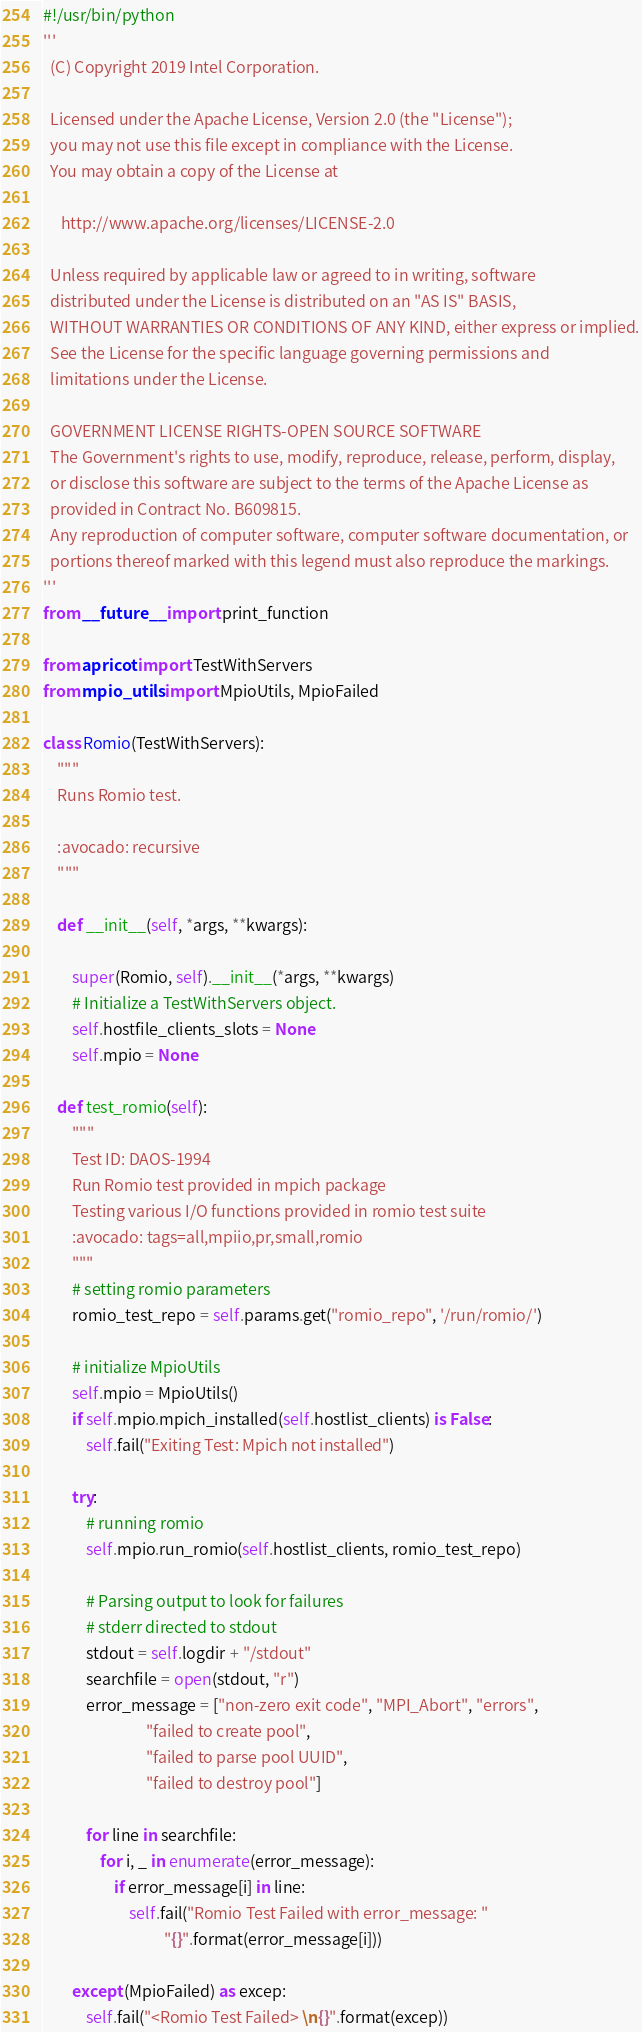<code> <loc_0><loc_0><loc_500><loc_500><_Python_>#!/usr/bin/python
'''
  (C) Copyright 2019 Intel Corporation.

  Licensed under the Apache License, Version 2.0 (the "License");
  you may not use this file except in compliance with the License.
  You may obtain a copy of the License at

     http://www.apache.org/licenses/LICENSE-2.0

  Unless required by applicable law or agreed to in writing, software
  distributed under the License is distributed on an "AS IS" BASIS,
  WITHOUT WARRANTIES OR CONDITIONS OF ANY KIND, either express or implied.
  See the License for the specific language governing permissions and
  limitations under the License.

  GOVERNMENT LICENSE RIGHTS-OPEN SOURCE SOFTWARE
  The Government's rights to use, modify, reproduce, release, perform, display,
  or disclose this software are subject to the terms of the Apache License as
  provided in Contract No. B609815.
  Any reproduction of computer software, computer software documentation, or
  portions thereof marked with this legend must also reproduce the markings.
'''
from __future__ import print_function

from apricot import TestWithServers
from mpio_utils import MpioUtils, MpioFailed

class Romio(TestWithServers):
    """
    Runs Romio test.

    :avocado: recursive
    """

    def __init__(self, *args, **kwargs):

        super(Romio, self).__init__(*args, **kwargs)
        # Initialize a TestWithServers object.
        self.hostfile_clients_slots = None
        self.mpio = None

    def test_romio(self):
        """
        Test ID: DAOS-1994
        Run Romio test provided in mpich package
        Testing various I/O functions provided in romio test suite
        :avocado: tags=all,mpiio,pr,small,romio
        """
        # setting romio parameters
        romio_test_repo = self.params.get("romio_repo", '/run/romio/')

        # initialize MpioUtils
        self.mpio = MpioUtils()
        if self.mpio.mpich_installed(self.hostlist_clients) is False:
            self.fail("Exiting Test: Mpich not installed")

        try:
            # running romio
            self.mpio.run_romio(self.hostlist_clients, romio_test_repo)

            # Parsing output to look for failures
            # stderr directed to stdout
            stdout = self.logdir + "/stdout"
            searchfile = open(stdout, "r")
            error_message = ["non-zero exit code", "MPI_Abort", "errors",
                             "failed to create pool",
                             "failed to parse pool UUID",
                             "failed to destroy pool"]

            for line in searchfile:
                for i, _ in enumerate(error_message):
                    if error_message[i] in line:
                        self.fail("Romio Test Failed with error_message: "
                                  "{}".format(error_message[i]))

        except (MpioFailed) as excep:
            self.fail("<Romio Test Failed> \n{}".format(excep))
</code> 